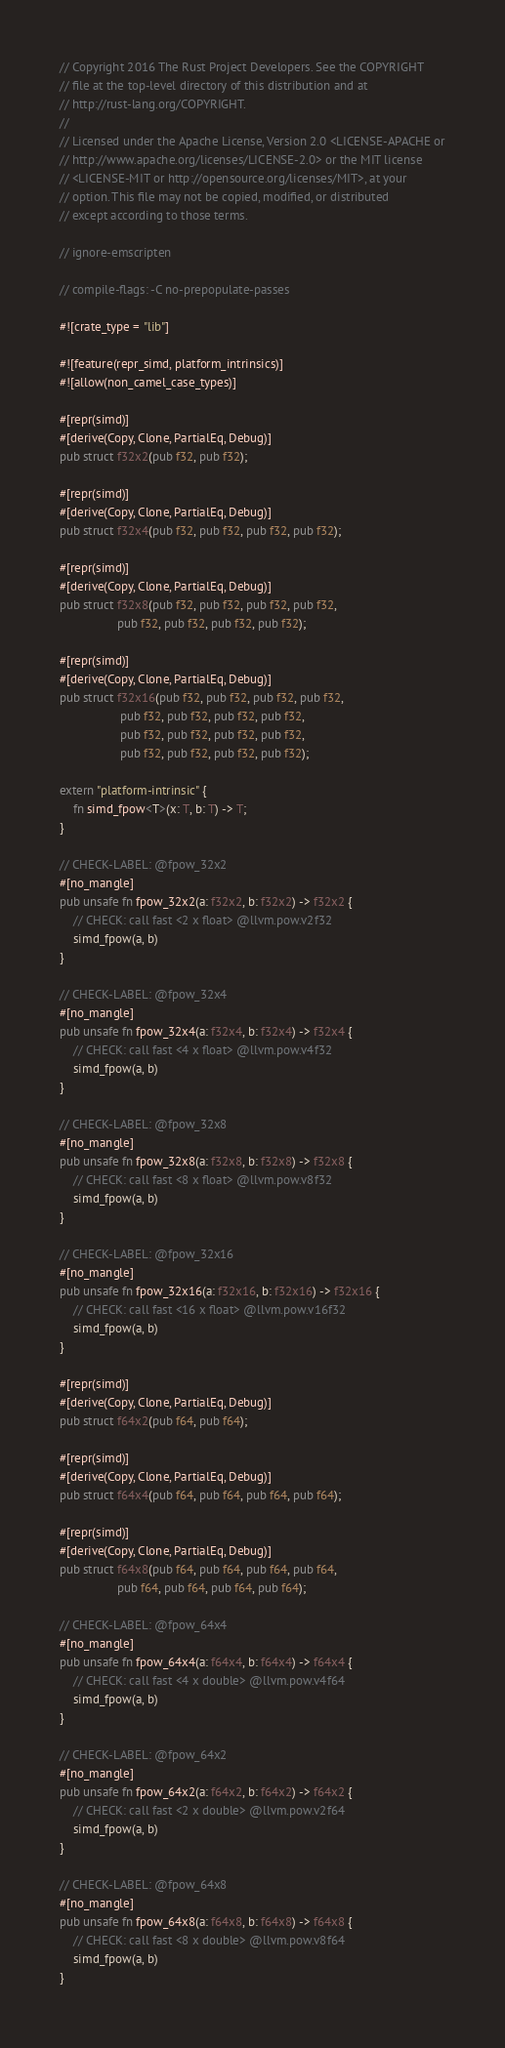Convert code to text. <code><loc_0><loc_0><loc_500><loc_500><_Rust_>// Copyright 2016 The Rust Project Developers. See the COPYRIGHT
// file at the top-level directory of this distribution and at
// http://rust-lang.org/COPYRIGHT.
//
// Licensed under the Apache License, Version 2.0 <LICENSE-APACHE or
// http://www.apache.org/licenses/LICENSE-2.0> or the MIT license
// <LICENSE-MIT or http://opensource.org/licenses/MIT>, at your
// option. This file may not be copied, modified, or distributed
// except according to those terms.

// ignore-emscripten

// compile-flags: -C no-prepopulate-passes

#![crate_type = "lib"]

#![feature(repr_simd, platform_intrinsics)]
#![allow(non_camel_case_types)]

#[repr(simd)]
#[derive(Copy, Clone, PartialEq, Debug)]
pub struct f32x2(pub f32, pub f32);

#[repr(simd)]
#[derive(Copy, Clone, PartialEq, Debug)]
pub struct f32x4(pub f32, pub f32, pub f32, pub f32);

#[repr(simd)]
#[derive(Copy, Clone, PartialEq, Debug)]
pub struct f32x8(pub f32, pub f32, pub f32, pub f32,
                 pub f32, pub f32, pub f32, pub f32);

#[repr(simd)]
#[derive(Copy, Clone, PartialEq, Debug)]
pub struct f32x16(pub f32, pub f32, pub f32, pub f32,
                  pub f32, pub f32, pub f32, pub f32,
                  pub f32, pub f32, pub f32, pub f32,
                  pub f32, pub f32, pub f32, pub f32);

extern "platform-intrinsic" {
    fn simd_fpow<T>(x: T, b: T) -> T;
}

// CHECK-LABEL: @fpow_32x2
#[no_mangle]
pub unsafe fn fpow_32x2(a: f32x2, b: f32x2) -> f32x2 {
    // CHECK: call fast <2 x float> @llvm.pow.v2f32
    simd_fpow(a, b)
}

// CHECK-LABEL: @fpow_32x4
#[no_mangle]
pub unsafe fn fpow_32x4(a: f32x4, b: f32x4) -> f32x4 {
    // CHECK: call fast <4 x float> @llvm.pow.v4f32
    simd_fpow(a, b)
}

// CHECK-LABEL: @fpow_32x8
#[no_mangle]
pub unsafe fn fpow_32x8(a: f32x8, b: f32x8) -> f32x8 {
    // CHECK: call fast <8 x float> @llvm.pow.v8f32
    simd_fpow(a, b)
}

// CHECK-LABEL: @fpow_32x16
#[no_mangle]
pub unsafe fn fpow_32x16(a: f32x16, b: f32x16) -> f32x16 {
    // CHECK: call fast <16 x float> @llvm.pow.v16f32
    simd_fpow(a, b)
}

#[repr(simd)]
#[derive(Copy, Clone, PartialEq, Debug)]
pub struct f64x2(pub f64, pub f64);

#[repr(simd)]
#[derive(Copy, Clone, PartialEq, Debug)]
pub struct f64x4(pub f64, pub f64, pub f64, pub f64);

#[repr(simd)]
#[derive(Copy, Clone, PartialEq, Debug)]
pub struct f64x8(pub f64, pub f64, pub f64, pub f64,
                 pub f64, pub f64, pub f64, pub f64);

// CHECK-LABEL: @fpow_64x4
#[no_mangle]
pub unsafe fn fpow_64x4(a: f64x4, b: f64x4) -> f64x4 {
    // CHECK: call fast <4 x double> @llvm.pow.v4f64
    simd_fpow(a, b)
}

// CHECK-LABEL: @fpow_64x2
#[no_mangle]
pub unsafe fn fpow_64x2(a: f64x2, b: f64x2) -> f64x2 {
    // CHECK: call fast <2 x double> @llvm.pow.v2f64
    simd_fpow(a, b)
}

// CHECK-LABEL: @fpow_64x8
#[no_mangle]
pub unsafe fn fpow_64x8(a: f64x8, b: f64x8) -> f64x8 {
    // CHECK: call fast <8 x double> @llvm.pow.v8f64
    simd_fpow(a, b)
}
</code> 